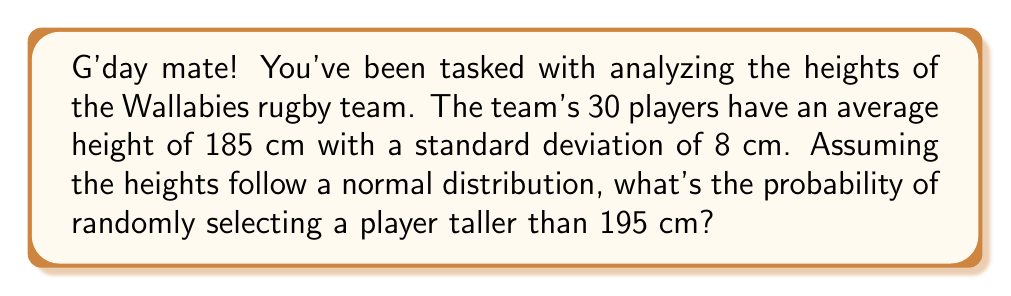Show me your answer to this math problem. Let's tackle this step-by-step, using the properties of the normal distribution:

1) We're given:
   - Mean height (μ) = 185 cm
   - Standard deviation (σ) = 8 cm
   - We want to find P(X > 195), where X is the height of a randomly selected player

2) To use the standard normal distribution, we need to calculate the z-score:

   $$ z = \frac{x - \mu}{\sigma} = \frac{195 - 185}{8} = 1.25 $$

3) Now, we need to find P(Z > 1.25) where Z is the standard normal variable

4) Using a standard normal table or calculator, we can find:

   $$ P(Z < 1.25) = 0.8944 $$

5) Since we want the probability of being greater than 1.25, we subtract from 1:

   $$ P(Z > 1.25) = 1 - P(Z < 1.25) = 1 - 0.8944 = 0.1056 $$

6) Convert to a percentage:

   $$ 0.1056 \times 100\% = 10.56\% $$

Therefore, the probability of randomly selecting a player taller than 195 cm is approximately 10.56%.
Answer: 10.56% 